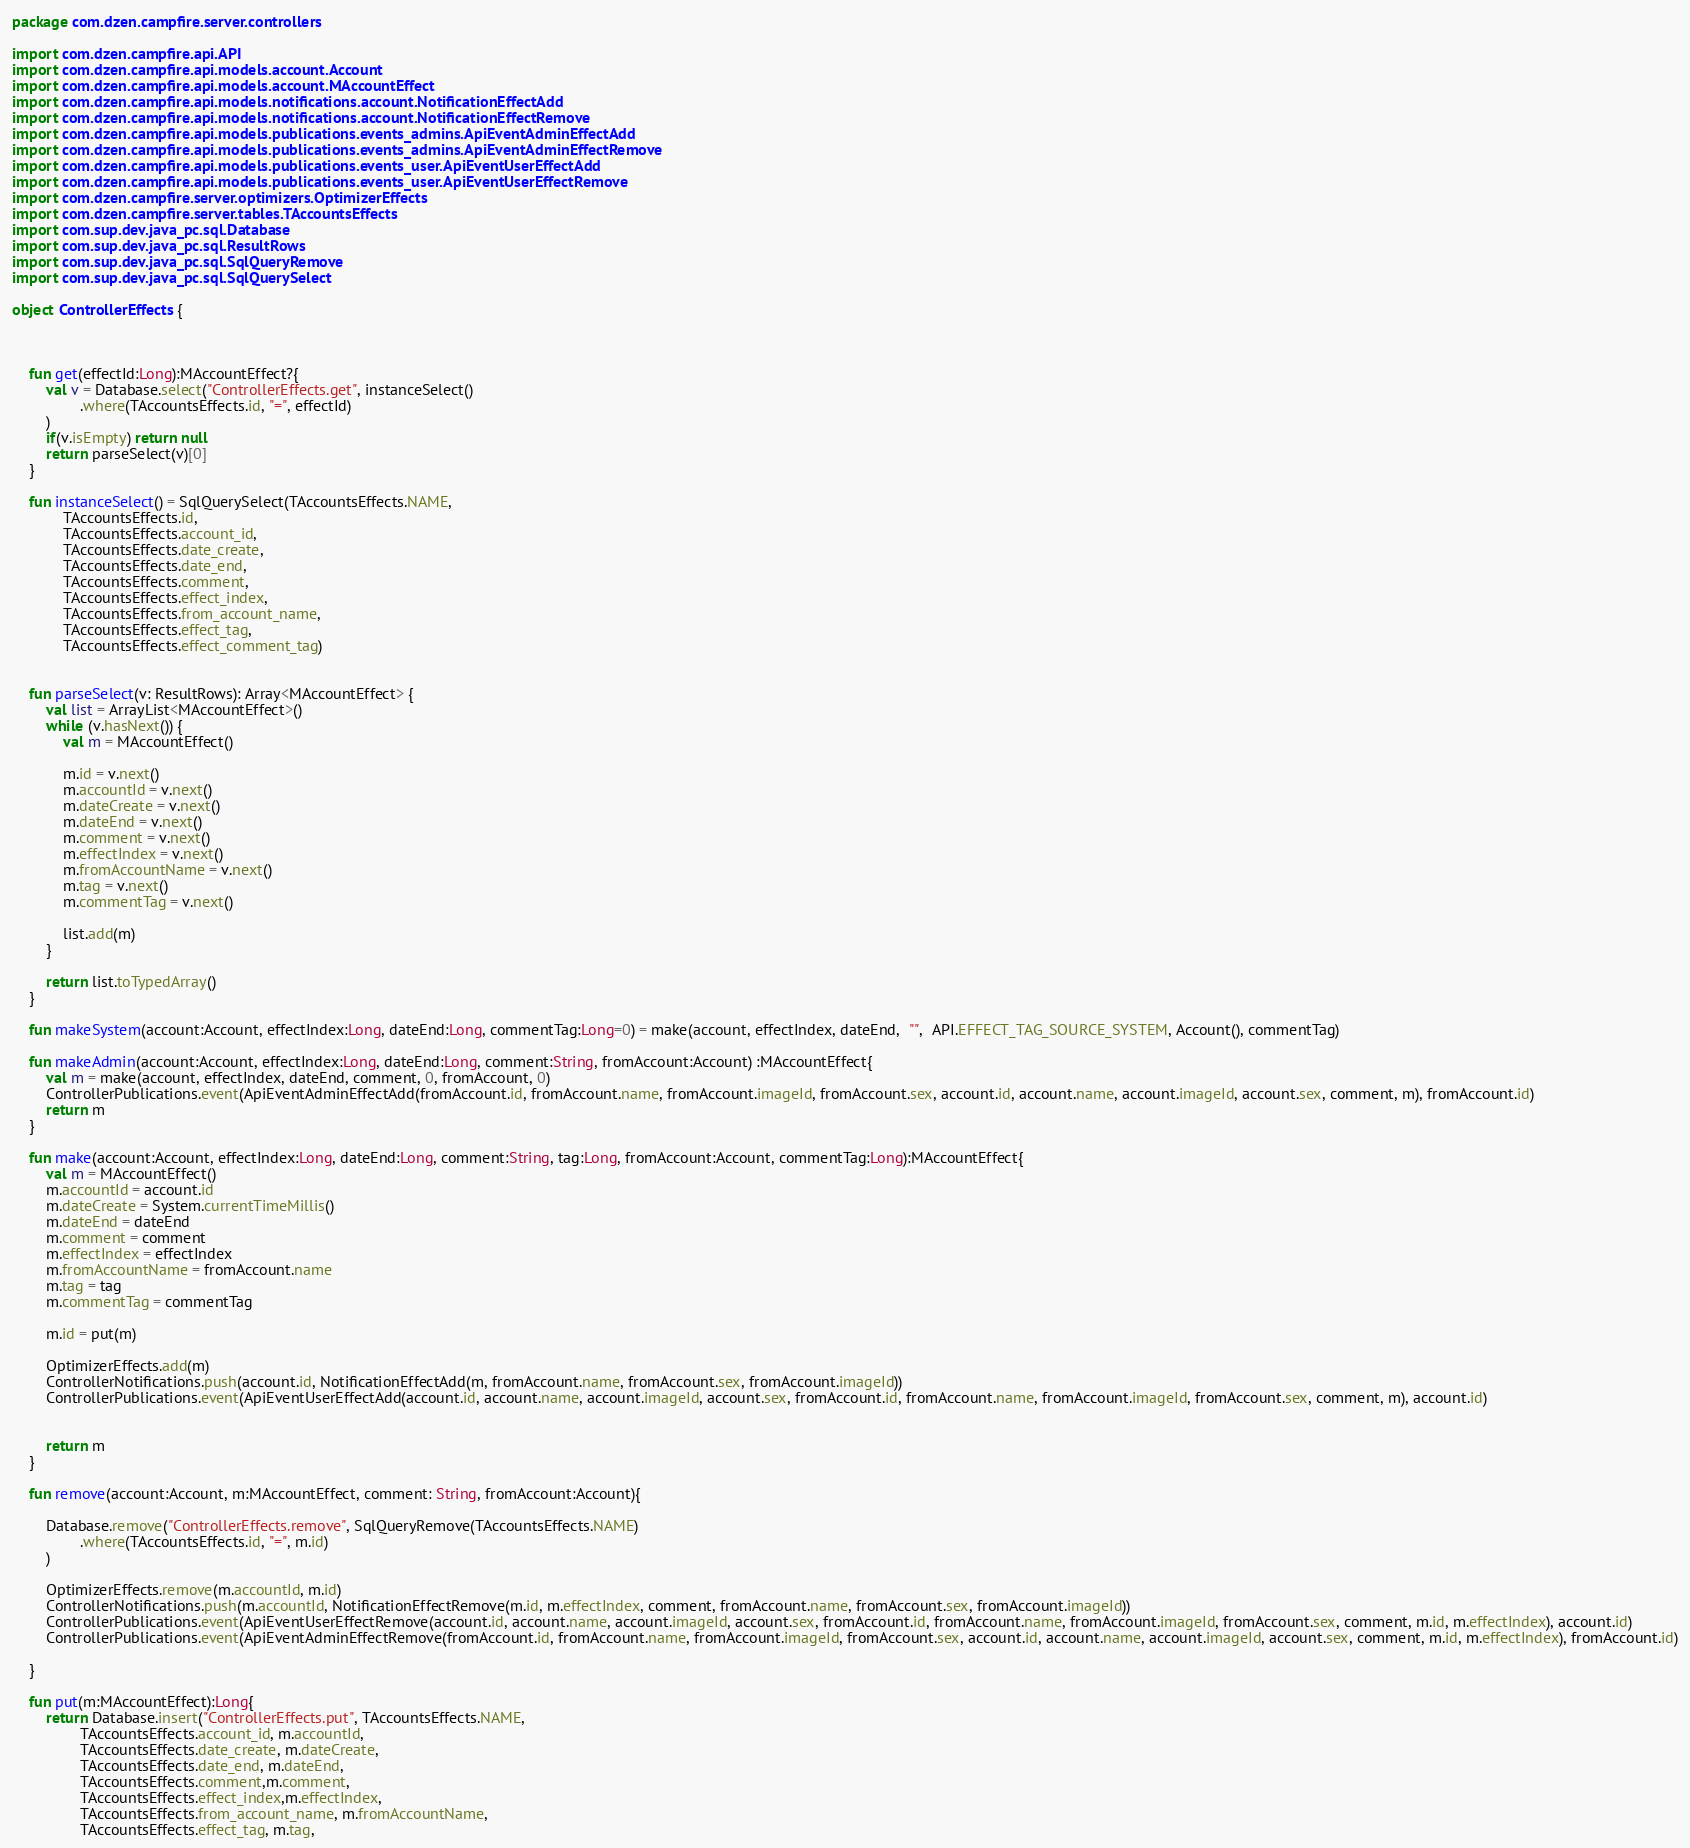<code> <loc_0><loc_0><loc_500><loc_500><_Kotlin_>package com.dzen.campfire.server.controllers

import com.dzen.campfire.api.API
import com.dzen.campfire.api.models.account.Account
import com.dzen.campfire.api.models.account.MAccountEffect
import com.dzen.campfire.api.models.notifications.account.NotificationEffectAdd
import com.dzen.campfire.api.models.notifications.account.NotificationEffectRemove
import com.dzen.campfire.api.models.publications.events_admins.ApiEventAdminEffectAdd
import com.dzen.campfire.api.models.publications.events_admins.ApiEventAdminEffectRemove
import com.dzen.campfire.api.models.publications.events_user.ApiEventUserEffectAdd
import com.dzen.campfire.api.models.publications.events_user.ApiEventUserEffectRemove
import com.dzen.campfire.server.optimizers.OptimizerEffects
import com.dzen.campfire.server.tables.TAccountsEffects
import com.sup.dev.java_pc.sql.Database
import com.sup.dev.java_pc.sql.ResultRows
import com.sup.dev.java_pc.sql.SqlQueryRemove
import com.sup.dev.java_pc.sql.SqlQuerySelect

object ControllerEffects {



    fun get(effectId:Long):MAccountEffect?{
        val v = Database.select("ControllerEffects.get", instanceSelect()
                .where(TAccountsEffects.id, "=", effectId)
        )
        if(v.isEmpty) return null
        return parseSelect(v)[0]
    }

    fun instanceSelect() = SqlQuerySelect(TAccountsEffects.NAME,
            TAccountsEffects.id,
            TAccountsEffects.account_id,
            TAccountsEffects.date_create,
            TAccountsEffects.date_end,
            TAccountsEffects.comment,
            TAccountsEffects.effect_index,
            TAccountsEffects.from_account_name,
            TAccountsEffects.effect_tag,
            TAccountsEffects.effect_comment_tag)


    fun parseSelect(v: ResultRows): Array<MAccountEffect> {
        val list = ArrayList<MAccountEffect>()
        while (v.hasNext()) {
            val m = MAccountEffect()

            m.id = v.next()
            m.accountId = v.next()
            m.dateCreate = v.next()
            m.dateEnd = v.next()
            m.comment = v.next()
            m.effectIndex = v.next()
            m.fromAccountName = v.next()
            m.tag = v.next()
            m.commentTag = v.next()

            list.add(m)
        }

        return list.toTypedArray()
    }

    fun makeSystem(account:Account, effectIndex:Long, dateEnd:Long, commentTag:Long=0) = make(account, effectIndex, dateEnd,  "",  API.EFFECT_TAG_SOURCE_SYSTEM, Account(), commentTag)

    fun makeAdmin(account:Account, effectIndex:Long, dateEnd:Long, comment:String, fromAccount:Account) :MAccountEffect{
        val m = make(account, effectIndex, dateEnd, comment, 0, fromAccount, 0)
        ControllerPublications.event(ApiEventAdminEffectAdd(fromAccount.id, fromAccount.name, fromAccount.imageId, fromAccount.sex, account.id, account.name, account.imageId, account.sex, comment, m), fromAccount.id)
        return m
    }

    fun make(account:Account, effectIndex:Long, dateEnd:Long, comment:String, tag:Long, fromAccount:Account, commentTag:Long):MAccountEffect{
        val m = MAccountEffect()
        m.accountId = account.id
        m.dateCreate = System.currentTimeMillis()
        m.dateEnd = dateEnd
        m.comment = comment
        m.effectIndex = effectIndex
        m.fromAccountName = fromAccount.name
        m.tag = tag
        m.commentTag = commentTag

        m.id = put(m)

        OptimizerEffects.add(m)
        ControllerNotifications.push(account.id, NotificationEffectAdd(m, fromAccount.name, fromAccount.sex, fromAccount.imageId))
        ControllerPublications.event(ApiEventUserEffectAdd(account.id, account.name, account.imageId, account.sex, fromAccount.id, fromAccount.name, fromAccount.imageId, fromAccount.sex, comment, m), account.id)


        return m
    }

    fun remove(account:Account, m:MAccountEffect, comment: String, fromAccount:Account){

        Database.remove("ControllerEffects.remove", SqlQueryRemove(TAccountsEffects.NAME)
                .where(TAccountsEffects.id, "=", m.id)
        )

        OptimizerEffects.remove(m.accountId, m.id)
        ControllerNotifications.push(m.accountId, NotificationEffectRemove(m.id, m.effectIndex, comment, fromAccount.name, fromAccount.sex, fromAccount.imageId))
        ControllerPublications.event(ApiEventUserEffectRemove(account.id, account.name, account.imageId, account.sex, fromAccount.id, fromAccount.name, fromAccount.imageId, fromAccount.sex, comment, m.id, m.effectIndex), account.id)
        ControllerPublications.event(ApiEventAdminEffectRemove(fromAccount.id, fromAccount.name, fromAccount.imageId, fromAccount.sex, account.id, account.name, account.imageId, account.sex, comment, m.id, m.effectIndex), fromAccount.id)

    }

    fun put(m:MAccountEffect):Long{
        return Database.insert("ControllerEffects.put", TAccountsEffects.NAME,
                TAccountsEffects.account_id, m.accountId,
                TAccountsEffects.date_create, m.dateCreate,
                TAccountsEffects.date_end, m.dateEnd,
                TAccountsEffects.comment,m.comment,
                TAccountsEffects.effect_index,m.effectIndex,
                TAccountsEffects.from_account_name, m.fromAccountName,
                TAccountsEffects.effect_tag, m.tag,</code> 